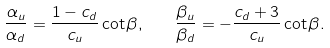<formula> <loc_0><loc_0><loc_500><loc_500>\frac { \alpha _ { u } } { \alpha _ { d } } = \frac { 1 - c _ { d } } { c _ { u } } \cot \beta , \quad \frac { \beta _ { u } } { \beta _ { d } } = - \frac { c _ { d } + 3 } { c _ { u } } \cot \beta .</formula> 